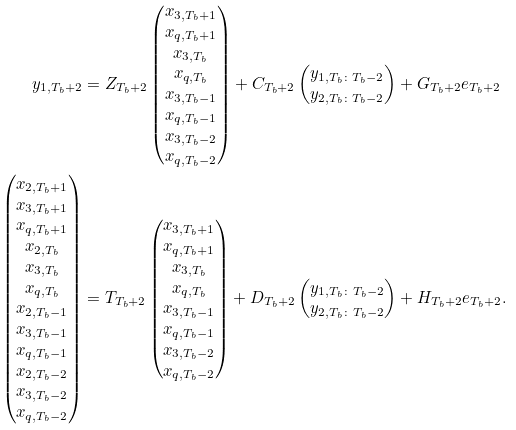<formula> <loc_0><loc_0><loc_500><loc_500>y _ { 1 , T _ { b } + 2 } & = Z _ { T _ { b } + 2 } \begin{pmatrix} x _ { 3 , T _ { b } + 1 } \\ x _ { q , { T _ { b } + 1 } } \\ x _ { 3 , T _ { b } } \\ x _ { q , { T _ { b } } } \\ x _ { 3 , T _ { b } - 1 } \\ x _ { q , { T _ { b } } - 1 } \\ x _ { 3 , T _ { b } - 2 } \\ x _ { q , { T _ { b } } - 2 } \end{pmatrix} + C _ { T _ { b } + 2 } \begin{pmatrix} y _ { 1 , T _ { b } \colon T _ { b } - 2 } \\ y _ { 2 , T _ { b } \colon T _ { b } - 2 } \end{pmatrix} + G _ { T _ { b } + 2 } e _ { T _ { b } + 2 } \\ \begin{pmatrix} x _ { 2 , T _ { b } + 1 } \\ x _ { 3 , T _ { b } + 1 } \\ x _ { q , { T _ { b } + 1 } } \\ x _ { 2 , T _ { b } } \\ x _ { 3 , T _ { b } } \\ x _ { q , { T _ { b } } } \\ x _ { 2 , T _ { b } - 1 } \\ x _ { 3 , T _ { b } - 1 } \\ x _ { q , { T _ { b } } - 1 } \\ x _ { 2 , T _ { b } - 2 } \\ x _ { 3 , T _ { b } - 2 } \\ x _ { q , { T _ { b } } - 2 } \end{pmatrix} & = T _ { T _ { b } + 2 } \begin{pmatrix} x _ { 3 , T _ { b } + 1 } \\ x _ { q , { T _ { b } + 1 } } \\ x _ { 3 , T _ { b } } \\ x _ { q , { T _ { b } } } \\ x _ { 3 , T _ { b } - 1 } \\ x _ { q , { T _ { b } } - 1 } \\ x _ { 3 , T _ { b } - 2 } \\ x _ { q , { T _ { b } } - 2 } \end{pmatrix} + D _ { T _ { b } + 2 } \begin{pmatrix} y _ { 1 , T _ { b } \colon T _ { b } - 2 } \\ y _ { 2 , T _ { b } \colon T _ { b } - 2 } \end{pmatrix} + H _ { T _ { b } + 2 } e _ { T _ { b } + 2 } .</formula> 